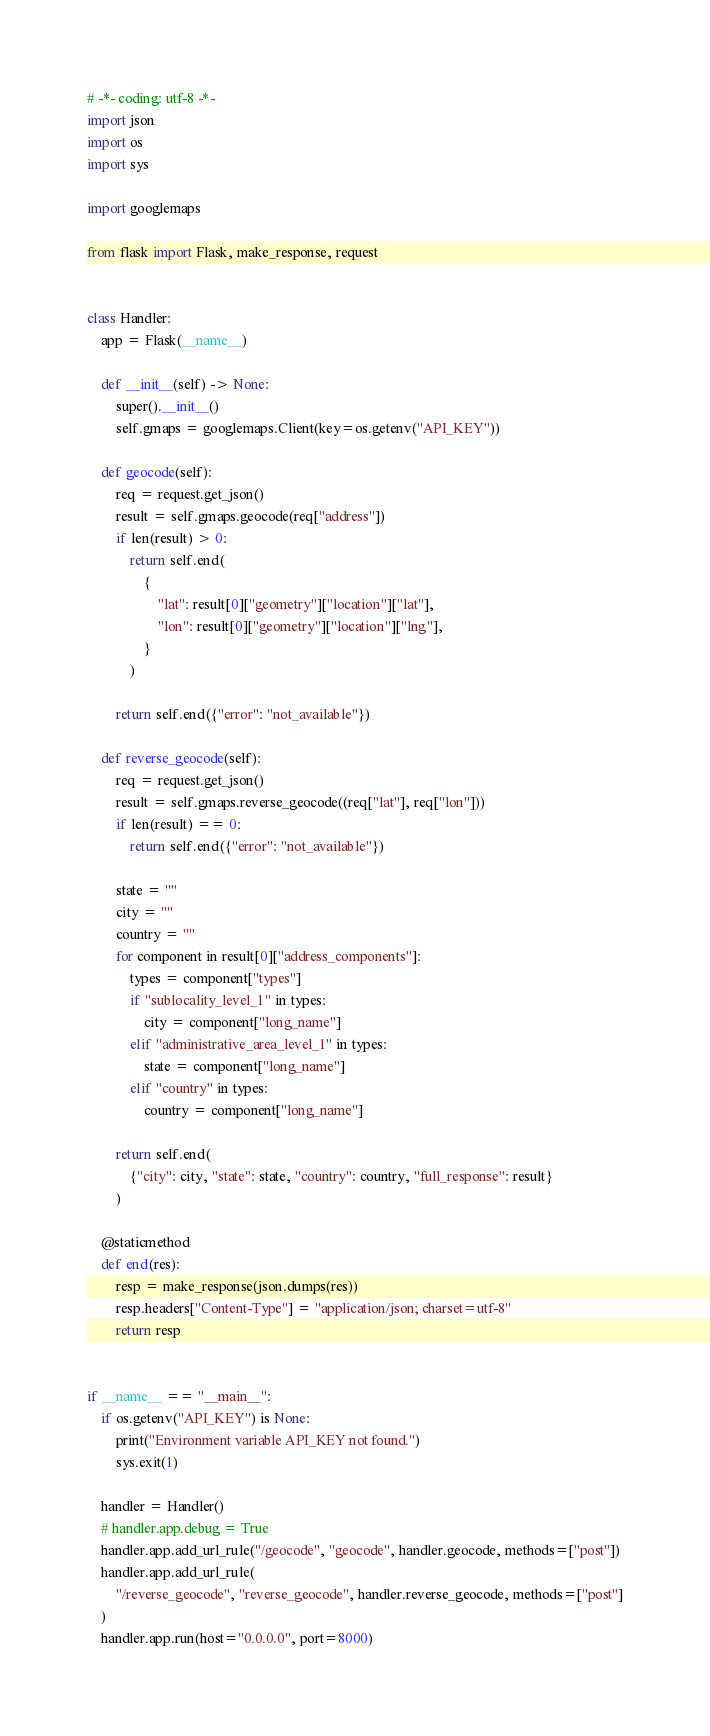Convert code to text. <code><loc_0><loc_0><loc_500><loc_500><_Python_># -*- coding: utf-8 -*-
import json
import os
import sys

import googlemaps

from flask import Flask, make_response, request


class Handler:
    app = Flask(__name__)

    def __init__(self) -> None:
        super().__init__()
        self.gmaps = googlemaps.Client(key=os.getenv("API_KEY"))

    def geocode(self):
        req = request.get_json()
        result = self.gmaps.geocode(req["address"])
        if len(result) > 0:
            return self.end(
                {
                    "lat": result[0]["geometry"]["location"]["lat"],
                    "lon": result[0]["geometry"]["location"]["lng"],
                }
            )

        return self.end({"error": "not_available"})

    def reverse_geocode(self):
        req = request.get_json()
        result = self.gmaps.reverse_geocode((req["lat"], req["lon"]))
        if len(result) == 0:
            return self.end({"error": "not_available"})

        state = ""
        city = ""
        country = ""
        for component in result[0]["address_components"]:
            types = component["types"]
            if "sublocality_level_1" in types:
                city = component["long_name"]
            elif "administrative_area_level_1" in types:
                state = component["long_name"]
            elif "country" in types:
                country = component["long_name"]

        return self.end(
            {"city": city, "state": state, "country": country, "full_response": result}
        )

    @staticmethod
    def end(res):
        resp = make_response(json.dumps(res))
        resp.headers["Content-Type"] = "application/json; charset=utf-8"
        return resp


if __name__ == "__main__":
    if os.getenv("API_KEY") is None:
        print("Environment variable API_KEY not found.")
        sys.exit(1)

    handler = Handler()
    # handler.app.debug = True
    handler.app.add_url_rule("/geocode", "geocode", handler.geocode, methods=["post"])
    handler.app.add_url_rule(
        "/reverse_geocode", "reverse_geocode", handler.reverse_geocode, methods=["post"]
    )
    handler.app.run(host="0.0.0.0", port=8000)
</code> 